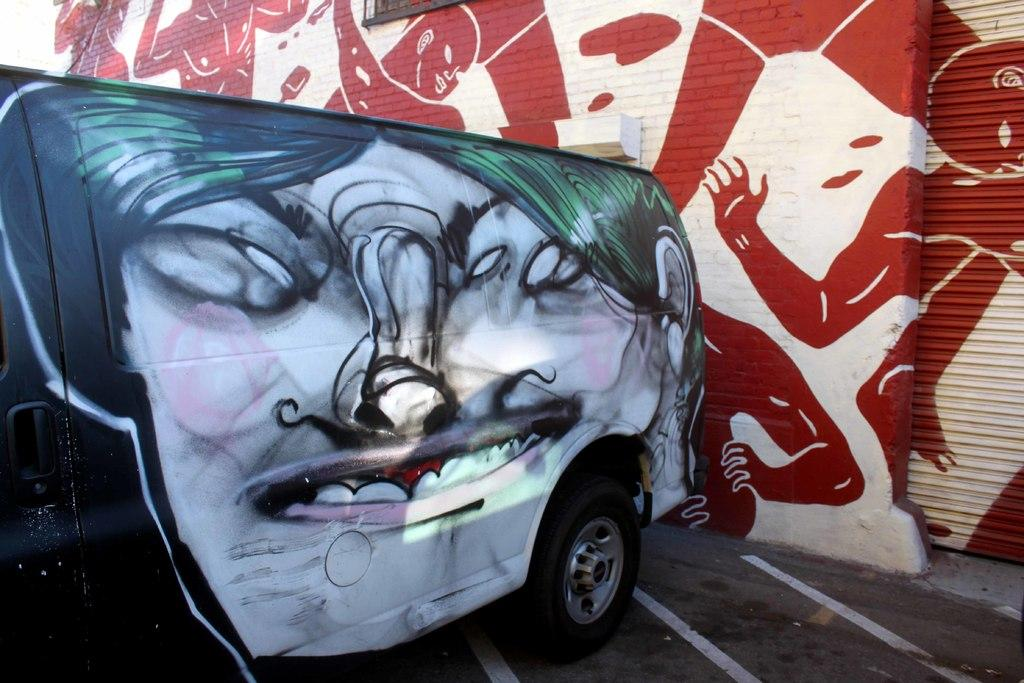What is the main subject of the image? There is a vehicle on the road in the image. What can be seen in the background of the image? There is a wall in the background of the image. What is located on the right side of the image? There is a shutter on the right side of the image. What grade did the vehicle receive for its performance in the image? There is no indication of a grade or performance evaluation in the image; it simply shows a vehicle on the road. 